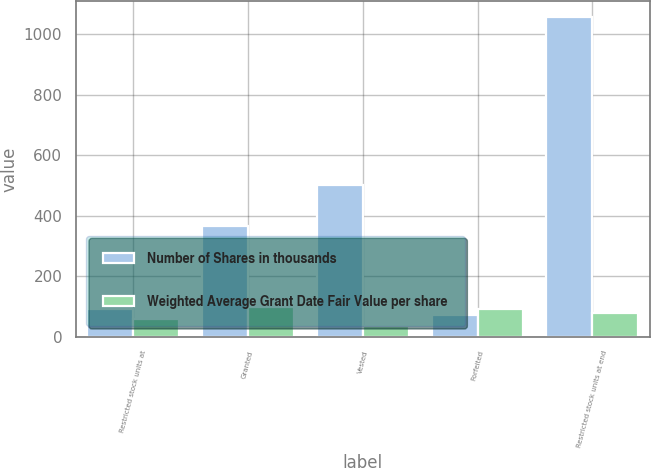<chart> <loc_0><loc_0><loc_500><loc_500><stacked_bar_chart><ecel><fcel>Restricted stock units at<fcel>Granted<fcel>Vested<fcel>Forfeited<fcel>Restricted stock units at end<nl><fcel>Number of Shares in thousands<fcel>91.39<fcel>366<fcel>502<fcel>71<fcel>1056<nl><fcel>Weighted Average Grant Date Fair Value per share<fcel>57.95<fcel>97.43<fcel>35.05<fcel>91.39<fcel>80.5<nl></chart> 